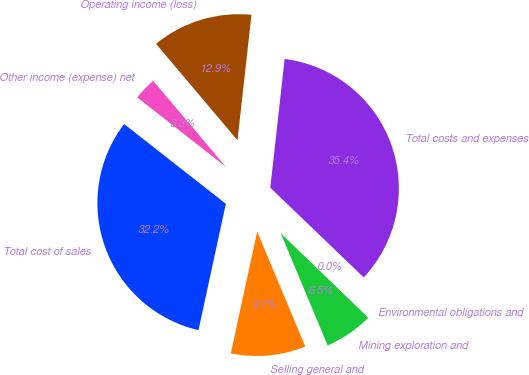Convert chart. <chart><loc_0><loc_0><loc_500><loc_500><pie_chart><fcel>Total cost of sales<fcel>Selling general and<fcel>Mining exploration and<fcel>Environmental obligations and<fcel>Total costs and expenses<fcel>Operating income (loss)<fcel>Other income (expense) net<nl><fcel>32.18%<fcel>9.7%<fcel>6.48%<fcel>0.04%<fcel>35.41%<fcel>12.93%<fcel>3.26%<nl></chart> 